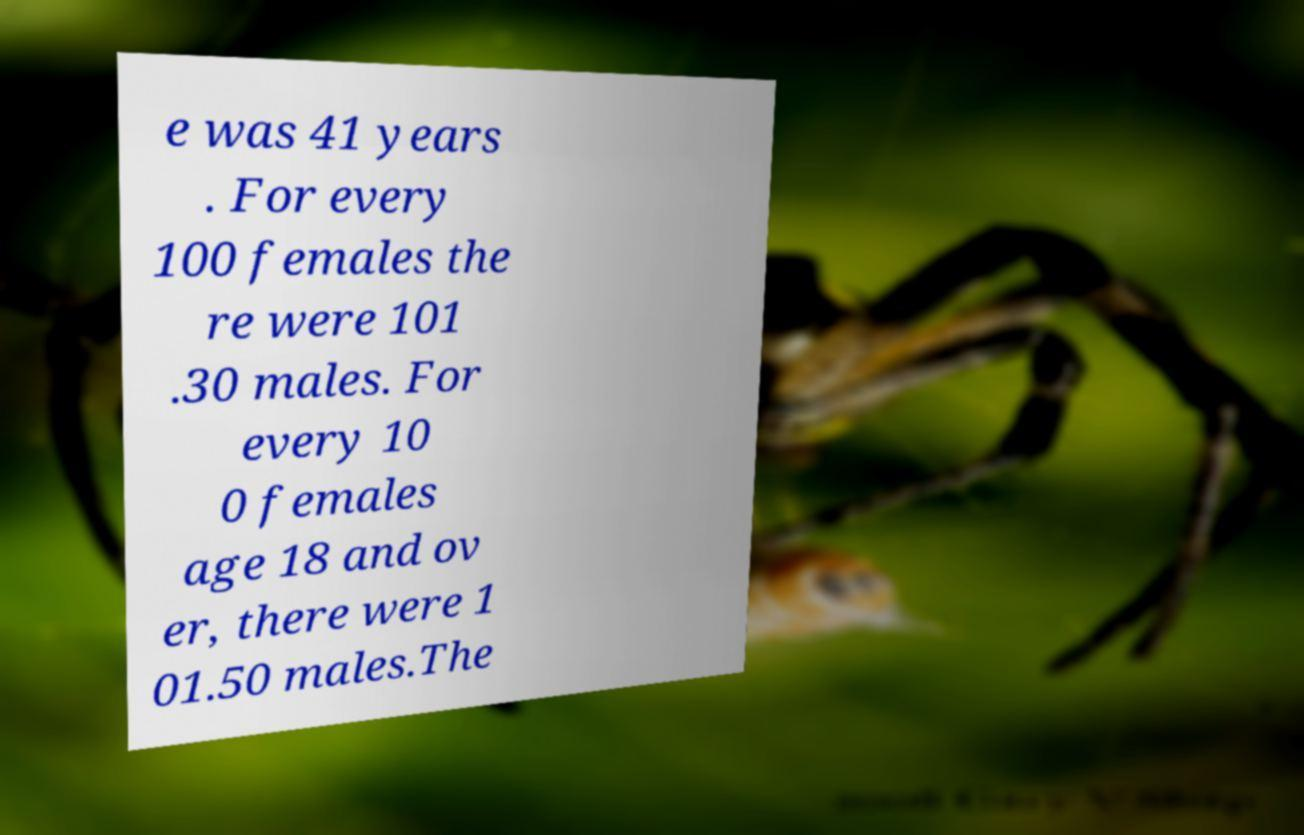I need the written content from this picture converted into text. Can you do that? e was 41 years . For every 100 females the re were 101 .30 males. For every 10 0 females age 18 and ov er, there were 1 01.50 males.The 